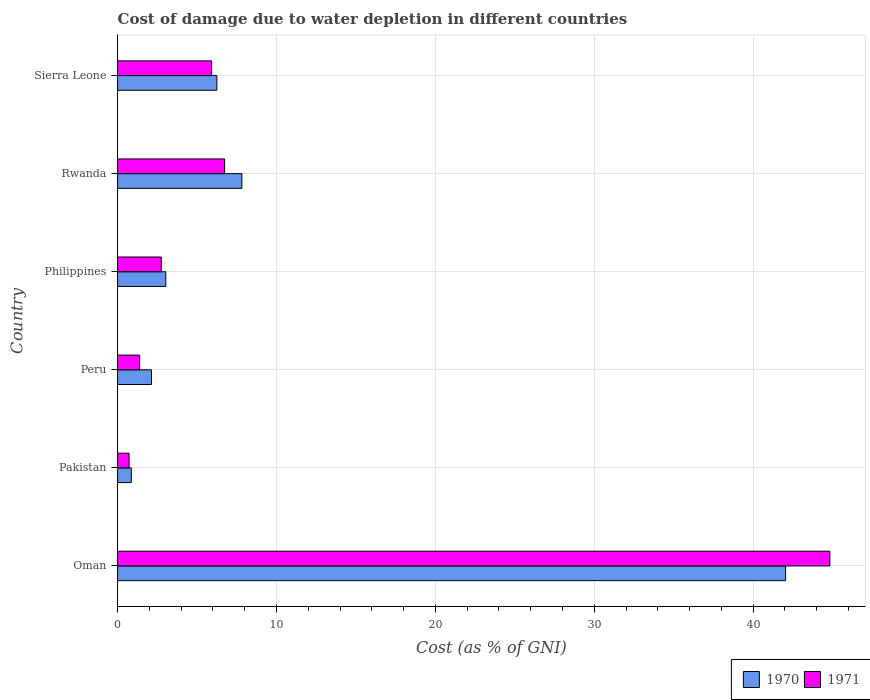How many different coloured bars are there?
Provide a succinct answer. 2. Are the number of bars per tick equal to the number of legend labels?
Your answer should be very brief. Yes. Are the number of bars on each tick of the Y-axis equal?
Ensure brevity in your answer.  Yes. How many bars are there on the 5th tick from the bottom?
Provide a short and direct response. 2. What is the label of the 3rd group of bars from the top?
Provide a short and direct response. Philippines. In how many cases, is the number of bars for a given country not equal to the number of legend labels?
Make the answer very short. 0. What is the cost of damage caused due to water depletion in 1970 in Rwanda?
Offer a terse response. 7.82. Across all countries, what is the maximum cost of damage caused due to water depletion in 1970?
Keep it short and to the point. 42.04. Across all countries, what is the minimum cost of damage caused due to water depletion in 1970?
Your answer should be compact. 0.86. In which country was the cost of damage caused due to water depletion in 1971 maximum?
Provide a short and direct response. Oman. In which country was the cost of damage caused due to water depletion in 1970 minimum?
Your answer should be very brief. Pakistan. What is the total cost of damage caused due to water depletion in 1971 in the graph?
Make the answer very short. 62.33. What is the difference between the cost of damage caused due to water depletion in 1970 in Pakistan and that in Sierra Leone?
Your answer should be very brief. -5.39. What is the difference between the cost of damage caused due to water depletion in 1970 in Rwanda and the cost of damage caused due to water depletion in 1971 in Oman?
Give a very brief answer. -37.01. What is the average cost of damage caused due to water depletion in 1970 per country?
Offer a very short reply. 10.36. What is the difference between the cost of damage caused due to water depletion in 1971 and cost of damage caused due to water depletion in 1970 in Oman?
Offer a very short reply. 2.79. What is the ratio of the cost of damage caused due to water depletion in 1970 in Pakistan to that in Philippines?
Provide a short and direct response. 0.28. Is the cost of damage caused due to water depletion in 1971 in Oman less than that in Rwanda?
Provide a succinct answer. No. What is the difference between the highest and the second highest cost of damage caused due to water depletion in 1970?
Offer a terse response. 34.22. What is the difference between the highest and the lowest cost of damage caused due to water depletion in 1970?
Your answer should be compact. 41.18. Are all the bars in the graph horizontal?
Offer a terse response. Yes. How many countries are there in the graph?
Ensure brevity in your answer.  6. What is the difference between two consecutive major ticks on the X-axis?
Give a very brief answer. 10. Are the values on the major ticks of X-axis written in scientific E-notation?
Your answer should be very brief. No. Does the graph contain any zero values?
Provide a short and direct response. No. Does the graph contain grids?
Your answer should be compact. Yes. How are the legend labels stacked?
Provide a succinct answer. Horizontal. What is the title of the graph?
Make the answer very short. Cost of damage due to water depletion in different countries. Does "1974" appear as one of the legend labels in the graph?
Your answer should be compact. No. What is the label or title of the X-axis?
Your answer should be very brief. Cost (as % of GNI). What is the Cost (as % of GNI) of 1970 in Oman?
Offer a very short reply. 42.04. What is the Cost (as % of GNI) of 1971 in Oman?
Give a very brief answer. 44.83. What is the Cost (as % of GNI) of 1970 in Pakistan?
Give a very brief answer. 0.86. What is the Cost (as % of GNI) in 1971 in Pakistan?
Give a very brief answer. 0.72. What is the Cost (as % of GNI) in 1970 in Peru?
Offer a terse response. 2.13. What is the Cost (as % of GNI) in 1971 in Peru?
Make the answer very short. 1.39. What is the Cost (as % of GNI) in 1970 in Philippines?
Your answer should be very brief. 3.03. What is the Cost (as % of GNI) in 1971 in Philippines?
Keep it short and to the point. 2.75. What is the Cost (as % of GNI) of 1970 in Rwanda?
Provide a succinct answer. 7.82. What is the Cost (as % of GNI) in 1971 in Rwanda?
Your answer should be compact. 6.73. What is the Cost (as % of GNI) of 1970 in Sierra Leone?
Give a very brief answer. 6.25. What is the Cost (as % of GNI) in 1971 in Sierra Leone?
Give a very brief answer. 5.92. Across all countries, what is the maximum Cost (as % of GNI) of 1970?
Ensure brevity in your answer.  42.04. Across all countries, what is the maximum Cost (as % of GNI) in 1971?
Provide a succinct answer. 44.83. Across all countries, what is the minimum Cost (as % of GNI) in 1970?
Provide a short and direct response. 0.86. Across all countries, what is the minimum Cost (as % of GNI) of 1971?
Provide a succinct answer. 0.72. What is the total Cost (as % of GNI) in 1970 in the graph?
Provide a short and direct response. 62.13. What is the total Cost (as % of GNI) in 1971 in the graph?
Offer a terse response. 62.33. What is the difference between the Cost (as % of GNI) in 1970 in Oman and that in Pakistan?
Make the answer very short. 41.18. What is the difference between the Cost (as % of GNI) in 1971 in Oman and that in Pakistan?
Provide a succinct answer. 44.1. What is the difference between the Cost (as % of GNI) in 1970 in Oman and that in Peru?
Give a very brief answer. 39.9. What is the difference between the Cost (as % of GNI) of 1971 in Oman and that in Peru?
Offer a very short reply. 43.44. What is the difference between the Cost (as % of GNI) in 1970 in Oman and that in Philippines?
Offer a very short reply. 39.01. What is the difference between the Cost (as % of GNI) in 1971 in Oman and that in Philippines?
Offer a terse response. 42.08. What is the difference between the Cost (as % of GNI) of 1970 in Oman and that in Rwanda?
Offer a terse response. 34.22. What is the difference between the Cost (as % of GNI) of 1971 in Oman and that in Rwanda?
Ensure brevity in your answer.  38.09. What is the difference between the Cost (as % of GNI) of 1970 in Oman and that in Sierra Leone?
Give a very brief answer. 35.79. What is the difference between the Cost (as % of GNI) in 1971 in Oman and that in Sierra Leone?
Offer a terse response. 38.91. What is the difference between the Cost (as % of GNI) of 1970 in Pakistan and that in Peru?
Offer a very short reply. -1.27. What is the difference between the Cost (as % of GNI) of 1971 in Pakistan and that in Peru?
Give a very brief answer. -0.66. What is the difference between the Cost (as % of GNI) in 1970 in Pakistan and that in Philippines?
Provide a succinct answer. -2.17. What is the difference between the Cost (as % of GNI) in 1971 in Pakistan and that in Philippines?
Give a very brief answer. -2.03. What is the difference between the Cost (as % of GNI) in 1970 in Pakistan and that in Rwanda?
Make the answer very short. -6.96. What is the difference between the Cost (as % of GNI) in 1971 in Pakistan and that in Rwanda?
Offer a very short reply. -6.01. What is the difference between the Cost (as % of GNI) of 1970 in Pakistan and that in Sierra Leone?
Your response must be concise. -5.39. What is the difference between the Cost (as % of GNI) of 1971 in Pakistan and that in Sierra Leone?
Give a very brief answer. -5.2. What is the difference between the Cost (as % of GNI) of 1970 in Peru and that in Philippines?
Offer a terse response. -0.9. What is the difference between the Cost (as % of GNI) of 1971 in Peru and that in Philippines?
Keep it short and to the point. -1.36. What is the difference between the Cost (as % of GNI) in 1970 in Peru and that in Rwanda?
Provide a short and direct response. -5.68. What is the difference between the Cost (as % of GNI) of 1971 in Peru and that in Rwanda?
Give a very brief answer. -5.35. What is the difference between the Cost (as % of GNI) of 1970 in Peru and that in Sierra Leone?
Offer a very short reply. -4.11. What is the difference between the Cost (as % of GNI) in 1971 in Peru and that in Sierra Leone?
Offer a terse response. -4.53. What is the difference between the Cost (as % of GNI) of 1970 in Philippines and that in Rwanda?
Ensure brevity in your answer.  -4.79. What is the difference between the Cost (as % of GNI) of 1971 in Philippines and that in Rwanda?
Make the answer very short. -3.99. What is the difference between the Cost (as % of GNI) of 1970 in Philippines and that in Sierra Leone?
Keep it short and to the point. -3.22. What is the difference between the Cost (as % of GNI) of 1971 in Philippines and that in Sierra Leone?
Give a very brief answer. -3.17. What is the difference between the Cost (as % of GNI) of 1970 in Rwanda and that in Sierra Leone?
Offer a terse response. 1.57. What is the difference between the Cost (as % of GNI) of 1971 in Rwanda and that in Sierra Leone?
Offer a terse response. 0.82. What is the difference between the Cost (as % of GNI) of 1970 in Oman and the Cost (as % of GNI) of 1971 in Pakistan?
Keep it short and to the point. 41.32. What is the difference between the Cost (as % of GNI) of 1970 in Oman and the Cost (as % of GNI) of 1971 in Peru?
Provide a short and direct response. 40.65. What is the difference between the Cost (as % of GNI) of 1970 in Oman and the Cost (as % of GNI) of 1971 in Philippines?
Give a very brief answer. 39.29. What is the difference between the Cost (as % of GNI) of 1970 in Oman and the Cost (as % of GNI) of 1971 in Rwanda?
Keep it short and to the point. 35.3. What is the difference between the Cost (as % of GNI) in 1970 in Oman and the Cost (as % of GNI) in 1971 in Sierra Leone?
Ensure brevity in your answer.  36.12. What is the difference between the Cost (as % of GNI) of 1970 in Pakistan and the Cost (as % of GNI) of 1971 in Peru?
Your response must be concise. -0.52. What is the difference between the Cost (as % of GNI) of 1970 in Pakistan and the Cost (as % of GNI) of 1971 in Philippines?
Give a very brief answer. -1.89. What is the difference between the Cost (as % of GNI) of 1970 in Pakistan and the Cost (as % of GNI) of 1971 in Rwanda?
Give a very brief answer. -5.87. What is the difference between the Cost (as % of GNI) in 1970 in Pakistan and the Cost (as % of GNI) in 1971 in Sierra Leone?
Your answer should be compact. -5.06. What is the difference between the Cost (as % of GNI) in 1970 in Peru and the Cost (as % of GNI) in 1971 in Philippines?
Offer a terse response. -0.62. What is the difference between the Cost (as % of GNI) in 1970 in Peru and the Cost (as % of GNI) in 1971 in Rwanda?
Provide a succinct answer. -4.6. What is the difference between the Cost (as % of GNI) in 1970 in Peru and the Cost (as % of GNI) in 1971 in Sierra Leone?
Give a very brief answer. -3.78. What is the difference between the Cost (as % of GNI) in 1970 in Philippines and the Cost (as % of GNI) in 1971 in Rwanda?
Your answer should be compact. -3.7. What is the difference between the Cost (as % of GNI) of 1970 in Philippines and the Cost (as % of GNI) of 1971 in Sierra Leone?
Give a very brief answer. -2.88. What is the difference between the Cost (as % of GNI) in 1970 in Rwanda and the Cost (as % of GNI) in 1971 in Sierra Leone?
Offer a terse response. 1.9. What is the average Cost (as % of GNI) of 1970 per country?
Offer a very short reply. 10.36. What is the average Cost (as % of GNI) of 1971 per country?
Keep it short and to the point. 10.39. What is the difference between the Cost (as % of GNI) in 1970 and Cost (as % of GNI) in 1971 in Oman?
Keep it short and to the point. -2.79. What is the difference between the Cost (as % of GNI) in 1970 and Cost (as % of GNI) in 1971 in Pakistan?
Provide a short and direct response. 0.14. What is the difference between the Cost (as % of GNI) in 1970 and Cost (as % of GNI) in 1971 in Peru?
Offer a very short reply. 0.75. What is the difference between the Cost (as % of GNI) in 1970 and Cost (as % of GNI) in 1971 in Philippines?
Provide a short and direct response. 0.28. What is the difference between the Cost (as % of GNI) of 1970 and Cost (as % of GNI) of 1971 in Rwanda?
Offer a terse response. 1.08. What is the difference between the Cost (as % of GNI) of 1970 and Cost (as % of GNI) of 1971 in Sierra Leone?
Provide a succinct answer. 0.33. What is the ratio of the Cost (as % of GNI) in 1970 in Oman to that in Pakistan?
Your response must be concise. 48.82. What is the ratio of the Cost (as % of GNI) in 1971 in Oman to that in Pakistan?
Offer a very short reply. 62.14. What is the ratio of the Cost (as % of GNI) in 1970 in Oman to that in Peru?
Ensure brevity in your answer.  19.7. What is the ratio of the Cost (as % of GNI) of 1971 in Oman to that in Peru?
Provide a short and direct response. 32.36. What is the ratio of the Cost (as % of GNI) in 1970 in Oman to that in Philippines?
Give a very brief answer. 13.86. What is the ratio of the Cost (as % of GNI) of 1971 in Oman to that in Philippines?
Keep it short and to the point. 16.31. What is the ratio of the Cost (as % of GNI) in 1970 in Oman to that in Rwanda?
Offer a very short reply. 5.38. What is the ratio of the Cost (as % of GNI) in 1971 in Oman to that in Rwanda?
Offer a very short reply. 6.66. What is the ratio of the Cost (as % of GNI) of 1970 in Oman to that in Sierra Leone?
Your response must be concise. 6.73. What is the ratio of the Cost (as % of GNI) in 1971 in Oman to that in Sierra Leone?
Provide a succinct answer. 7.58. What is the ratio of the Cost (as % of GNI) of 1970 in Pakistan to that in Peru?
Your answer should be very brief. 0.4. What is the ratio of the Cost (as % of GNI) in 1971 in Pakistan to that in Peru?
Make the answer very short. 0.52. What is the ratio of the Cost (as % of GNI) of 1970 in Pakistan to that in Philippines?
Keep it short and to the point. 0.28. What is the ratio of the Cost (as % of GNI) of 1971 in Pakistan to that in Philippines?
Ensure brevity in your answer.  0.26. What is the ratio of the Cost (as % of GNI) in 1970 in Pakistan to that in Rwanda?
Make the answer very short. 0.11. What is the ratio of the Cost (as % of GNI) of 1971 in Pakistan to that in Rwanda?
Keep it short and to the point. 0.11. What is the ratio of the Cost (as % of GNI) in 1970 in Pakistan to that in Sierra Leone?
Offer a terse response. 0.14. What is the ratio of the Cost (as % of GNI) of 1971 in Pakistan to that in Sierra Leone?
Provide a succinct answer. 0.12. What is the ratio of the Cost (as % of GNI) of 1970 in Peru to that in Philippines?
Your answer should be compact. 0.7. What is the ratio of the Cost (as % of GNI) of 1971 in Peru to that in Philippines?
Your answer should be very brief. 0.5. What is the ratio of the Cost (as % of GNI) in 1970 in Peru to that in Rwanda?
Provide a succinct answer. 0.27. What is the ratio of the Cost (as % of GNI) of 1971 in Peru to that in Rwanda?
Offer a terse response. 0.21. What is the ratio of the Cost (as % of GNI) of 1970 in Peru to that in Sierra Leone?
Provide a succinct answer. 0.34. What is the ratio of the Cost (as % of GNI) of 1971 in Peru to that in Sierra Leone?
Your answer should be very brief. 0.23. What is the ratio of the Cost (as % of GNI) of 1970 in Philippines to that in Rwanda?
Give a very brief answer. 0.39. What is the ratio of the Cost (as % of GNI) of 1971 in Philippines to that in Rwanda?
Your answer should be compact. 0.41. What is the ratio of the Cost (as % of GNI) of 1970 in Philippines to that in Sierra Leone?
Keep it short and to the point. 0.49. What is the ratio of the Cost (as % of GNI) in 1971 in Philippines to that in Sierra Leone?
Offer a terse response. 0.46. What is the ratio of the Cost (as % of GNI) in 1970 in Rwanda to that in Sierra Leone?
Provide a short and direct response. 1.25. What is the ratio of the Cost (as % of GNI) of 1971 in Rwanda to that in Sierra Leone?
Ensure brevity in your answer.  1.14. What is the difference between the highest and the second highest Cost (as % of GNI) in 1970?
Provide a succinct answer. 34.22. What is the difference between the highest and the second highest Cost (as % of GNI) of 1971?
Ensure brevity in your answer.  38.09. What is the difference between the highest and the lowest Cost (as % of GNI) in 1970?
Offer a very short reply. 41.18. What is the difference between the highest and the lowest Cost (as % of GNI) in 1971?
Offer a very short reply. 44.1. 